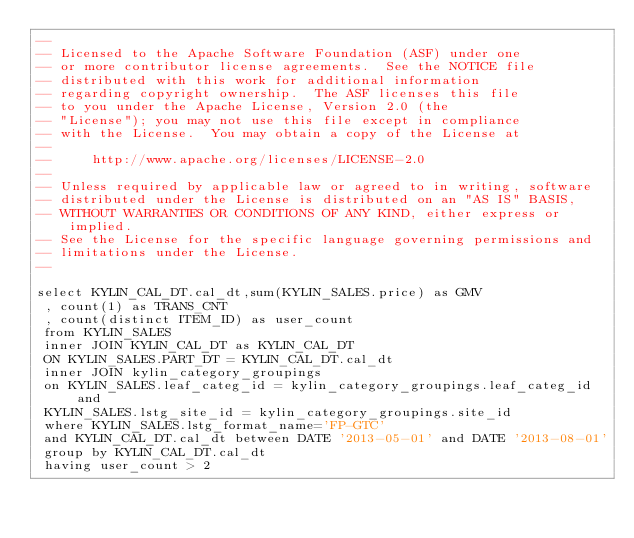<code> <loc_0><loc_0><loc_500><loc_500><_SQL_>--
-- Licensed to the Apache Software Foundation (ASF) under one
-- or more contributor license agreements.  See the NOTICE file
-- distributed with this work for additional information
-- regarding copyright ownership.  The ASF licenses this file
-- to you under the Apache License, Version 2.0 (the
-- "License"); you may not use this file except in compliance
-- with the License.  You may obtain a copy of the License at
--
--     http://www.apache.org/licenses/LICENSE-2.0
--
-- Unless required by applicable law or agreed to in writing, software
-- distributed under the License is distributed on an "AS IS" BASIS,
-- WITHOUT WARRANTIES OR CONDITIONS OF ANY KIND, either express or implied.
-- See the License for the specific language governing permissions and
-- limitations under the License.
--

select KYLIN_CAL_DT.cal_dt,sum(KYLIN_SALES.price) as GMV
 , count(1) as TRANS_CNT
 , count(distinct ITEM_ID) as user_count
 from KYLIN_SALES
 inner JOIN KYLIN_CAL_DT as KYLIN_CAL_DT
 ON KYLIN_SALES.PART_DT = KYLIN_CAL_DT.cal_dt
 inner JOIN kylin_category_groupings
 on KYLIN_SALES.leaf_categ_id = kylin_category_groupings.leaf_categ_id and
 KYLIN_SALES.lstg_site_id = kylin_category_groupings.site_id
 where KYLIN_SALES.lstg_format_name='FP-GTC'
 and KYLIN_CAL_DT.cal_dt between DATE '2013-05-01' and DATE '2013-08-01'
 group by KYLIN_CAL_DT.cal_dt
 having user_count > 2</code> 